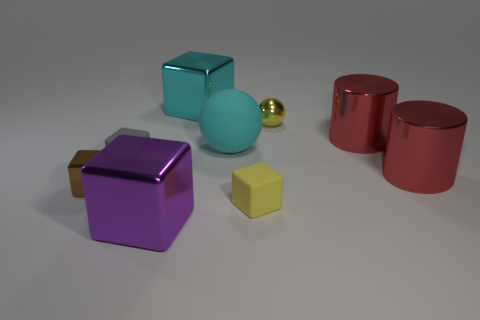There is a tiny yellow thing on the left side of the yellow object that is on the right side of the small yellow object that is in front of the tiny yellow sphere; what is it made of?
Give a very brief answer. Rubber. What is the shape of the small yellow object that is the same material as the gray block?
Make the answer very short. Cube. There is a object that is in front of the yellow block; is there a cyan rubber sphere that is in front of it?
Provide a short and direct response. No. How big is the brown shiny block?
Provide a short and direct response. Small. What number of things are small cyan matte balls or red metal objects?
Offer a very short reply. 2. Does the yellow object that is on the left side of the tiny ball have the same material as the big cube to the right of the purple cube?
Keep it short and to the point. No. What is the color of the other large cube that is made of the same material as the large purple cube?
Give a very brief answer. Cyan. How many cyan blocks have the same size as the cyan metallic object?
Give a very brief answer. 0. How many other things are the same color as the big ball?
Your answer should be compact. 1. Do the object to the left of the gray thing and the cyan object that is behind the big cyan rubber sphere have the same shape?
Provide a short and direct response. Yes. 